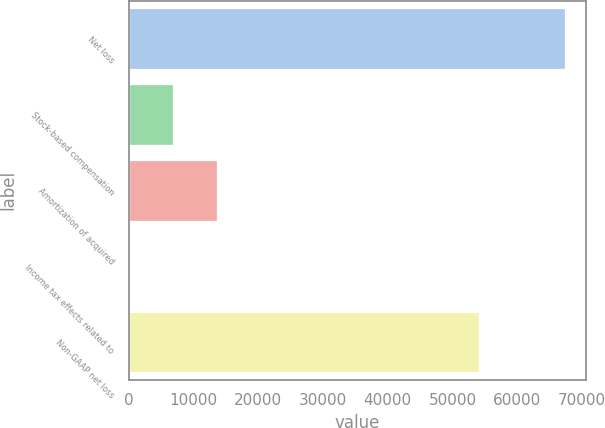Convert chart to OTSL. <chart><loc_0><loc_0><loc_500><loc_500><bar_chart><fcel>Net loss<fcel>Stock-based compensation<fcel>Amortization of acquired<fcel>Income tax effects related to<fcel>Non-GAAP net loss<nl><fcel>67324<fcel>6893.5<fcel>13608<fcel>179<fcel>54066<nl></chart> 